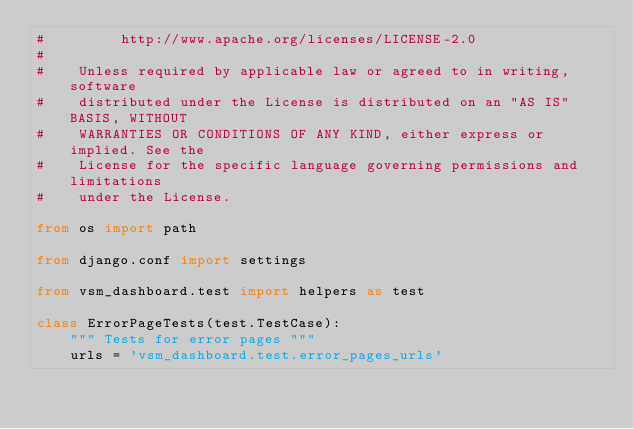Convert code to text. <code><loc_0><loc_0><loc_500><loc_500><_Python_>#         http://www.apache.org/licenses/LICENSE-2.0
#
#    Unless required by applicable law or agreed to in writing, software
#    distributed under the License is distributed on an "AS IS" BASIS, WITHOUT
#    WARRANTIES OR CONDITIONS OF ANY KIND, either express or implied. See the
#    License for the specific language governing permissions and limitations
#    under the License.

from os import path

from django.conf import settings

from vsm_dashboard.test import helpers as test

class ErrorPageTests(test.TestCase):
    """ Tests for error pages """
    urls = 'vsm_dashboard.test.error_pages_urls'
</code> 